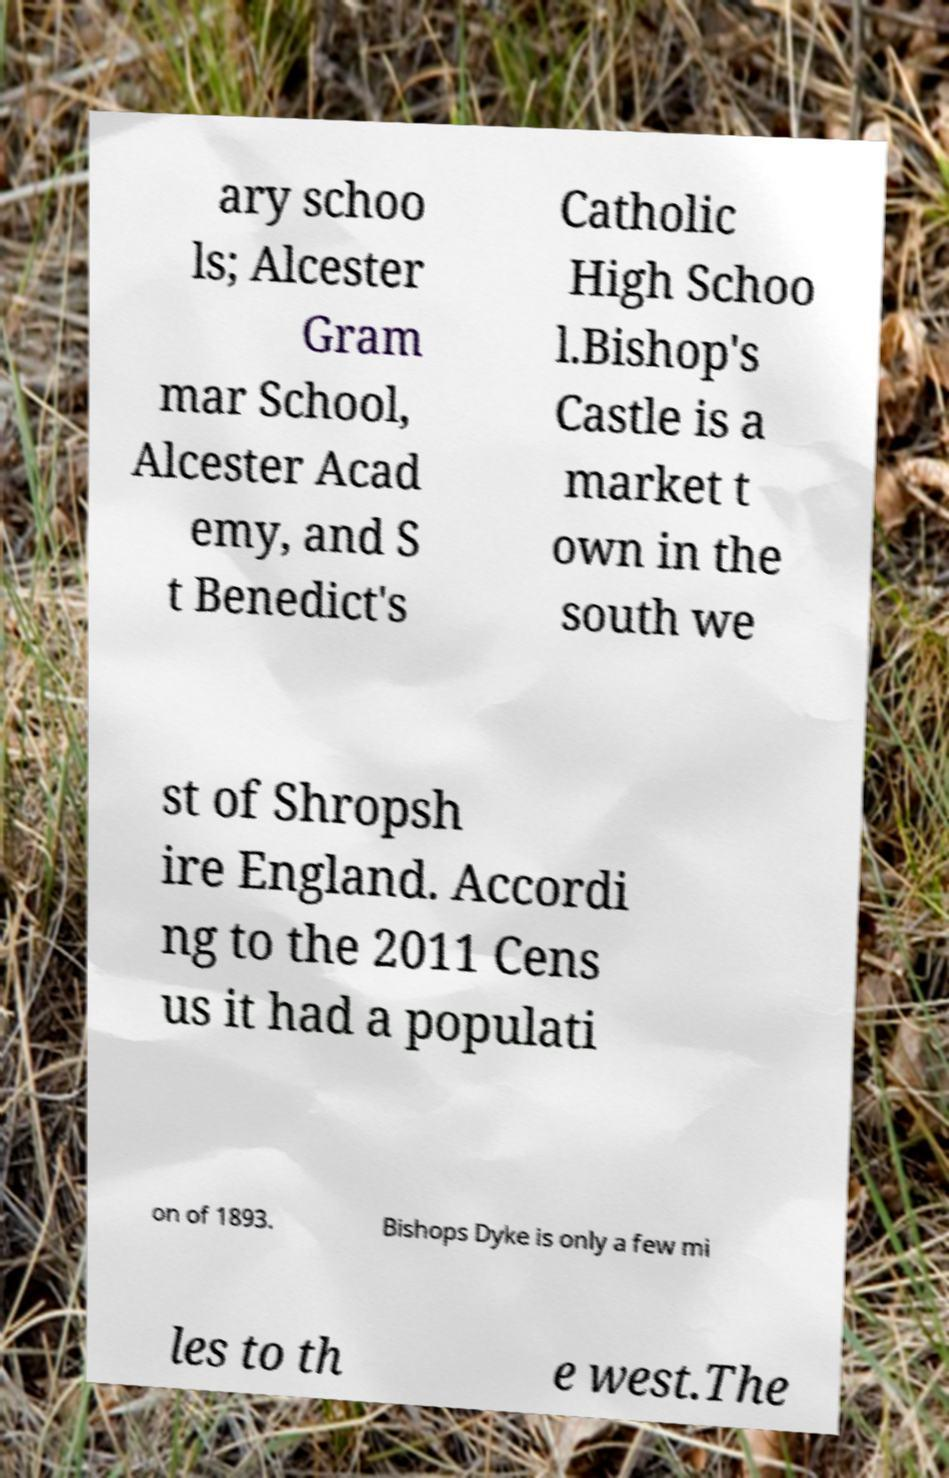For documentation purposes, I need the text within this image transcribed. Could you provide that? ary schoo ls; Alcester Gram mar School, Alcester Acad emy, and S t Benedict's Catholic High Schoo l.Bishop's Castle is a market t own in the south we st of Shropsh ire England. Accordi ng to the 2011 Cens us it had a populati on of 1893. Bishops Dyke is only a few mi les to th e west.The 